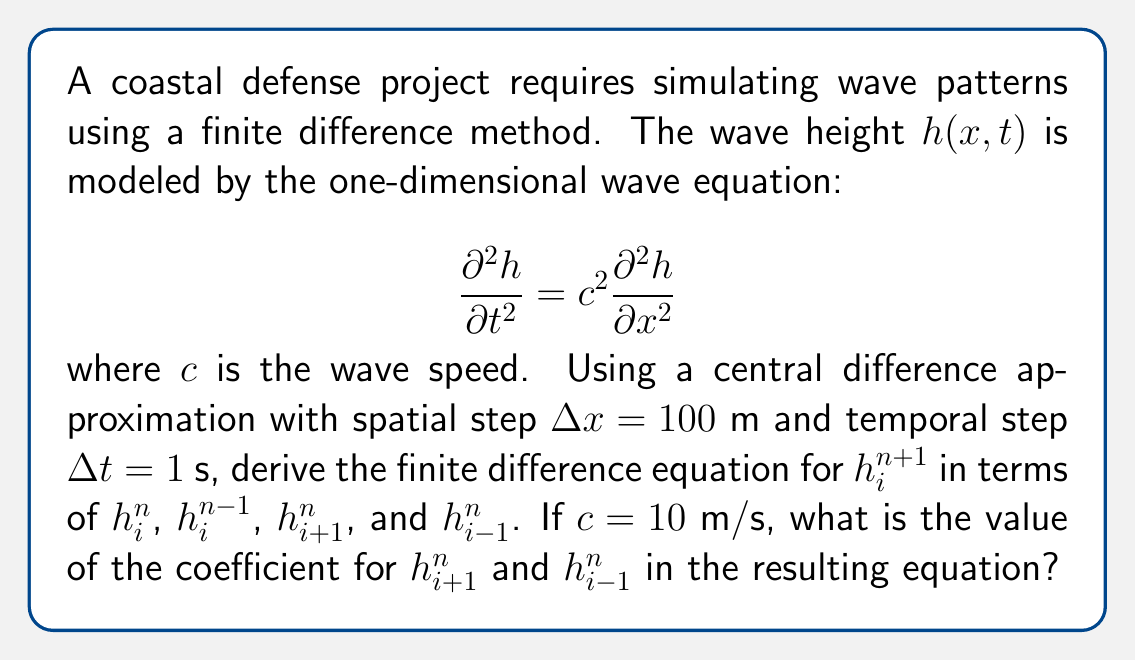Show me your answer to this math problem. Let's approach this step-by-step:

1) The central difference approximations for the second derivatives are:

   $$\frac{\partial^2 h}{\partial t^2} \approx \frac{h_i^{n+1} - 2h_i^n + h_i^{n-1}}{(\Delta t)^2}$$

   $$\frac{\partial^2 h}{\partial x^2} \approx \frac{h_{i+1}^n - 2h_i^n + h_{i-1}^n}{(\Delta x)^2}$$

2) Substituting these into the wave equation:

   $$\frac{h_i^{n+1} - 2h_i^n + h_i^{n-1}}{(\Delta t)^2} = c^2 \frac{h_{i+1}^n - 2h_i^n + h_{i-1}^n}{(\Delta x)^2}$$

3) Multiply both sides by $(\Delta t)^2$:

   $$h_i^{n+1} - 2h_i^n + h_i^{n-1} = c^2 \frac{(\Delta t)^2}{(\Delta x)^2} (h_{i+1}^n - 2h_i^n + h_{i-1}^n)$$

4) Let $r = c \frac{\Delta t}{\Delta x}$. Then $c^2 \frac{(\Delta t)^2}{(\Delta x)^2} = r^2$:

   $$h_i^{n+1} - 2h_i^n + h_i^{n-1} = r^2 (h_{i+1}^n - 2h_i^n + h_{i-1}^n)$$

5) Rearrange to solve for $h_i^{n+1}$:

   $$h_i^{n+1} = 2h_i^n - h_i^{n-1} + r^2 (h_{i+1}^n - 2h_i^n + h_{i-1}^n)$$
   $$h_i^{n+1} = 2(1-r^2)h_i^n - h_i^{n-1} + r^2(h_{i+1}^n + h_{i-1}^n)$$

6) Now, let's calculate $r$ with the given values:

   $$r = c \frac{\Delta t}{\Delta x} = 10 \frac{1}{100} = 0.1$$

7) Therefore, $r^2 = 0.01$, which is the coefficient for $h_{i+1}^n$ and $h_{i-1}^n$ in the equation.
Answer: 0.01 